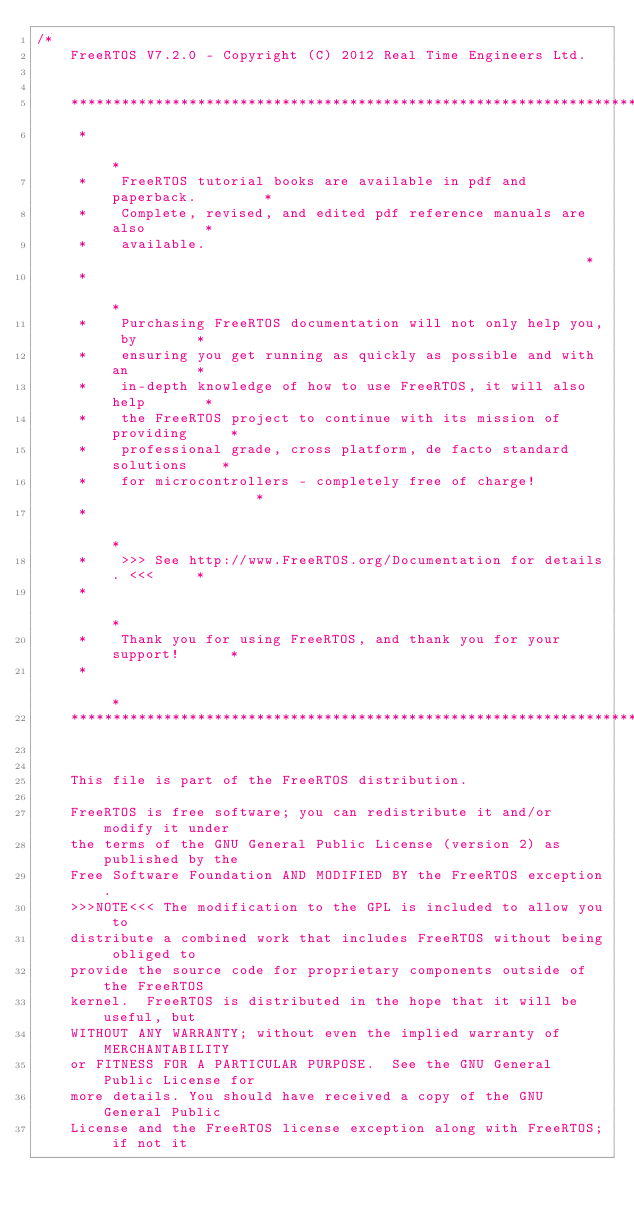<code> <loc_0><loc_0><loc_500><loc_500><_C_>/*
    FreeRTOS V7.2.0 - Copyright (C) 2012 Real Time Engineers Ltd.
	

    ***************************************************************************
     *                                                                       *
     *    FreeRTOS tutorial books are available in pdf and paperback.        *
     *    Complete, revised, and edited pdf reference manuals are also       *
     *    available.                                                         *
     *                                                                       *
     *    Purchasing FreeRTOS documentation will not only help you, by       *
     *    ensuring you get running as quickly as possible and with an        *
     *    in-depth knowledge of how to use FreeRTOS, it will also help       *
     *    the FreeRTOS project to continue with its mission of providing     *
     *    professional grade, cross platform, de facto standard solutions    *
     *    for microcontrollers - completely free of charge!                  *
     *                                                                       *
     *    >>> See http://www.FreeRTOS.org/Documentation for details. <<<     *
     *                                                                       *
     *    Thank you for using FreeRTOS, and thank you for your support!      *
     *                                                                       *
    ***************************************************************************


    This file is part of the FreeRTOS distribution.

    FreeRTOS is free software; you can redistribute it and/or modify it under
    the terms of the GNU General Public License (version 2) as published by the
    Free Software Foundation AND MODIFIED BY the FreeRTOS exception.
    >>>NOTE<<< The modification to the GPL is included to allow you to
    distribute a combined work that includes FreeRTOS without being obliged to
    provide the source code for proprietary components outside of the FreeRTOS
    kernel.  FreeRTOS is distributed in the hope that it will be useful, but
    WITHOUT ANY WARRANTY; without even the implied warranty of MERCHANTABILITY
    or FITNESS FOR A PARTICULAR PURPOSE.  See the GNU General Public License for
    more details. You should have received a copy of the GNU General Public
    License and the FreeRTOS license exception along with FreeRTOS; if not it</code> 